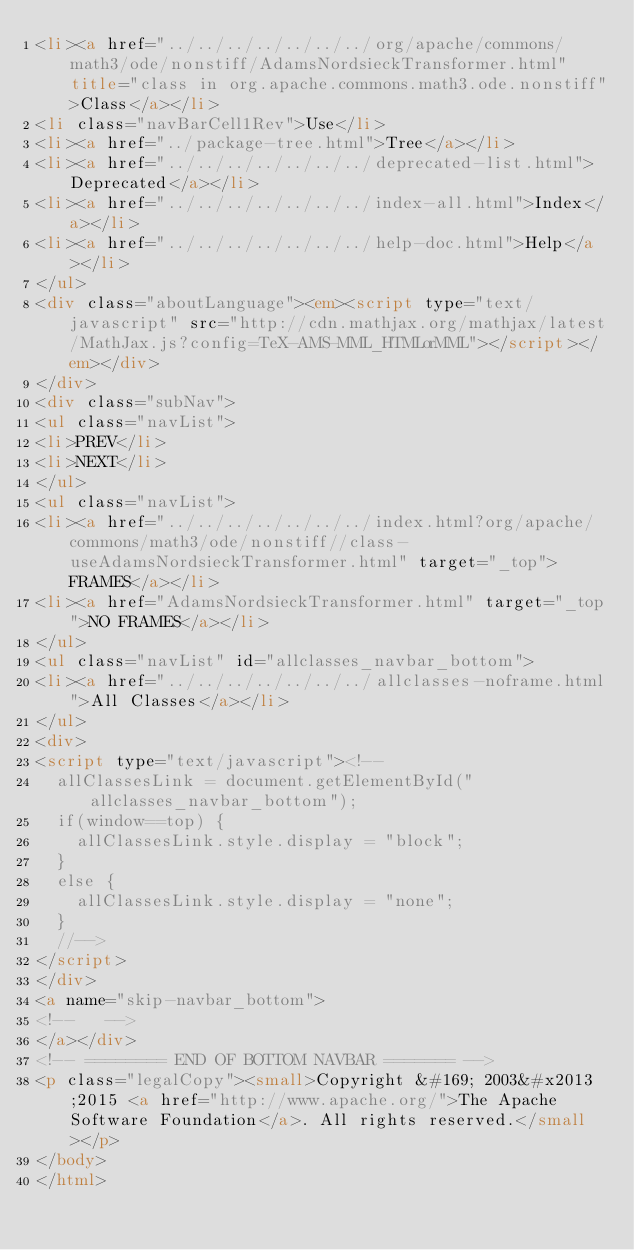<code> <loc_0><loc_0><loc_500><loc_500><_HTML_><li><a href="../../../../../../../org/apache/commons/math3/ode/nonstiff/AdamsNordsieckTransformer.html" title="class in org.apache.commons.math3.ode.nonstiff">Class</a></li>
<li class="navBarCell1Rev">Use</li>
<li><a href="../package-tree.html">Tree</a></li>
<li><a href="../../../../../../../deprecated-list.html">Deprecated</a></li>
<li><a href="../../../../../../../index-all.html">Index</a></li>
<li><a href="../../../../../../../help-doc.html">Help</a></li>
</ul>
<div class="aboutLanguage"><em><script type="text/javascript" src="http://cdn.mathjax.org/mathjax/latest/MathJax.js?config=TeX-AMS-MML_HTMLorMML"></script></em></div>
</div>
<div class="subNav">
<ul class="navList">
<li>PREV</li>
<li>NEXT</li>
</ul>
<ul class="navList">
<li><a href="../../../../../../../index.html?org/apache/commons/math3/ode/nonstiff//class-useAdamsNordsieckTransformer.html" target="_top">FRAMES</a></li>
<li><a href="AdamsNordsieckTransformer.html" target="_top">NO FRAMES</a></li>
</ul>
<ul class="navList" id="allclasses_navbar_bottom">
<li><a href="../../../../../../../allclasses-noframe.html">All Classes</a></li>
</ul>
<div>
<script type="text/javascript"><!--
  allClassesLink = document.getElementById("allclasses_navbar_bottom");
  if(window==top) {
    allClassesLink.style.display = "block";
  }
  else {
    allClassesLink.style.display = "none";
  }
  //-->
</script>
</div>
<a name="skip-navbar_bottom">
<!--   -->
</a></div>
<!-- ======== END OF BOTTOM NAVBAR ======= -->
<p class="legalCopy"><small>Copyright &#169; 2003&#x2013;2015 <a href="http://www.apache.org/">The Apache Software Foundation</a>. All rights reserved.</small></p>
</body>
</html>
</code> 